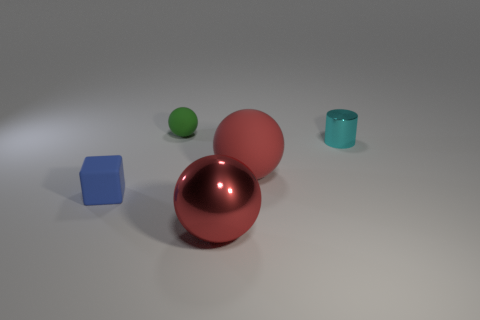How many rubber things are blocks or large green cubes? In the image, there are no rubber blocks or large green cubes. We can see one small green sphere, a teal cylinder which appears to be a cup, a blue cube, and two larger spheres, one of which is closer to the foreground. Based on visible materials, it's unclear if any of them are made of rubber without further context. 